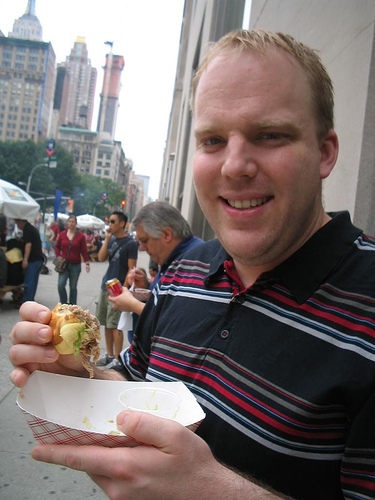<image>What color is the carton? I am not sure about the color of the carton. It can be 'red and white' or 'white'. What color is the carton? I am not sure what color the carton is. It can be seen as white, red and white, or white and red. 